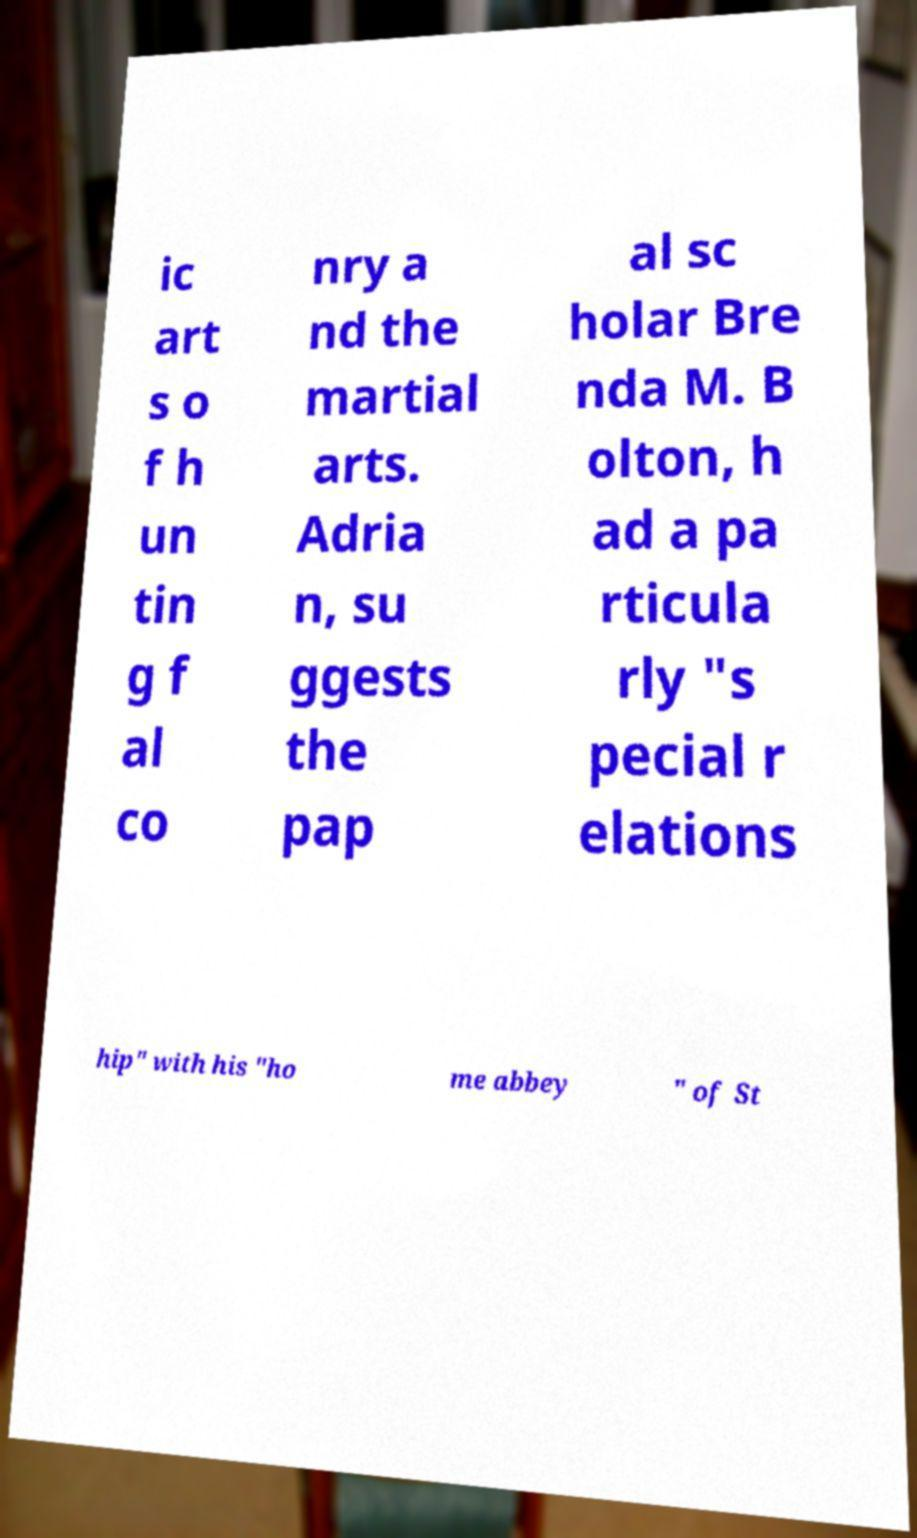Could you extract and type out the text from this image? ic art s o f h un tin g f al co nry a nd the martial arts. Adria n, su ggests the pap al sc holar Bre nda M. B olton, h ad a pa rticula rly "s pecial r elations hip" with his "ho me abbey " of St 